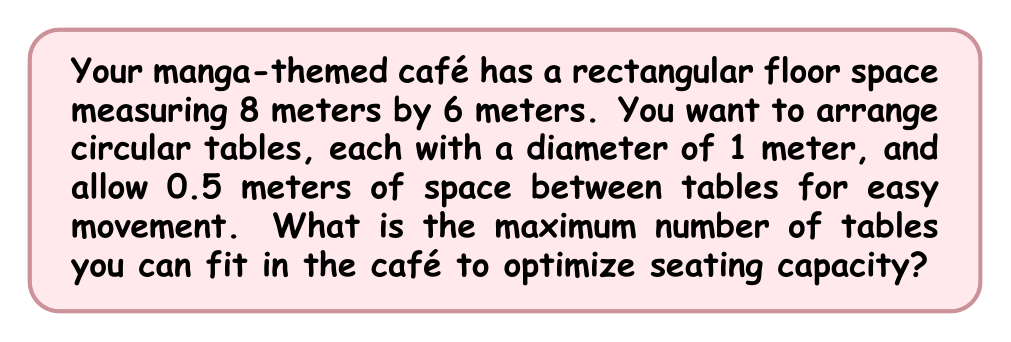Could you help me with this problem? Let's approach this step-by-step:

1) First, we need to calculate the effective space each table occupies, including the required spacing:
   Effective diameter = Table diameter + Spacing on both sides
   $$ 1 \text{ m} + 0.5 \text{ m} + 0.5 \text{ m} = 2 \text{ m} $$

2) Now, let's calculate how many tables can fit along the length and width:
   Length: $$ \text{Number of tables} = \left\lfloor\frac{8 \text{ m}}{2 \text{ m}}\right\rfloor = 4 $$
   Width: $$ \text{Number of tables} = \left\lfloor\frac{6 \text{ m}}{2 \text{ m}}\right\rfloor = 3 $$
   Where $\lfloor \cdot \rfloor$ denotes the floor function (rounding down).

3) The total number of tables is the product of these two numbers:
   $$ \text{Total tables} = 4 \times 3 = 12 $$

4) Let's verify if there's any remaining space:
   Length: $8 \text{ m} - (4 \times 2 \text{ m}) = 0 \text{ m}$
   Width: $6 \text{ m} - (3 \times 2 \text{ m}) = 0 \text{ m}$

   There's no remaining space, so our calculation is optimal.

Therefore, the maximum number of tables that can fit in the café while maintaining the required spacing is 12.
Answer: 12 tables 